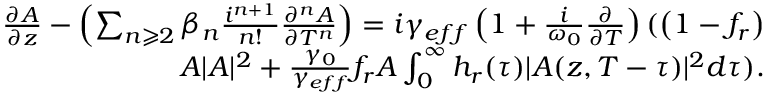Convert formula to latex. <formula><loc_0><loc_0><loc_500><loc_500>\begin{array} { r } { \frac { \partial A } { \partial z } - \left ( \sum _ { n \geqslant 2 } \beta _ { n } \frac { i ^ { n + 1 } } { n ! } \frac { \partial ^ { n } A } { \partial T ^ { n } } \right ) = i \gamma _ { e f f } \left ( 1 + \frac { i } { \omega _ { 0 } } \frac { \partial } { \partial T } \right ) ( \left ( 1 - f _ { r } \right ) } \\ { A | A | ^ { 2 } + \frac { \gamma _ { 0 } } { \gamma _ { e f f } } f _ { r } A \int _ { 0 } ^ { \infty } h _ { r } ( \tau ) | A ( z , T - \tau ) | ^ { 2 } d \tau ) . } \end{array}</formula> 